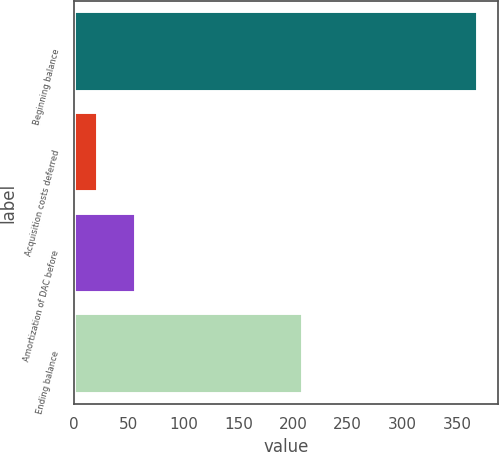Convert chart. <chart><loc_0><loc_0><loc_500><loc_500><bar_chart><fcel>Beginning balance<fcel>Acquisition costs deferred<fcel>Amortization of DAC before<fcel>Ending balance<nl><fcel>369<fcel>22<fcel>56.7<fcel>209<nl></chart> 